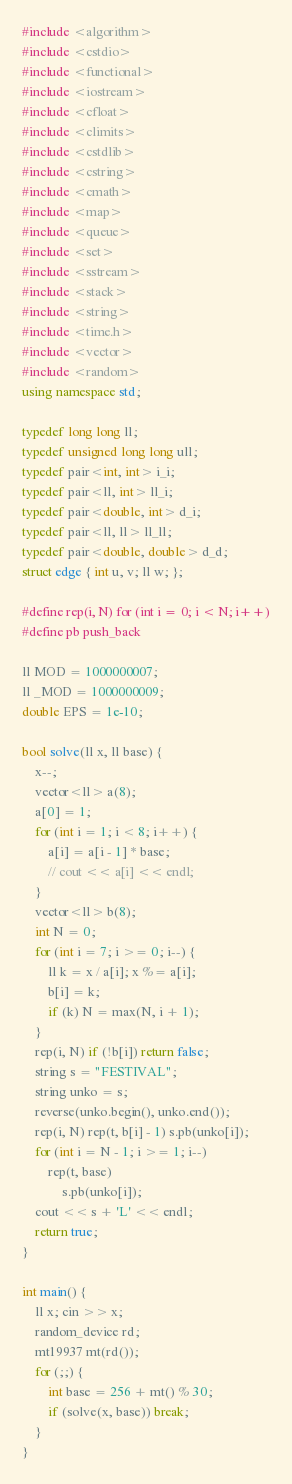<code> <loc_0><loc_0><loc_500><loc_500><_C++_>#include <algorithm>
#include <cstdio>
#include <functional>
#include <iostream>
#include <cfloat>
#include <climits>
#include <cstdlib>
#include <cstring>
#include <cmath>
#include <map>
#include <queue>
#include <set>
#include <sstream>
#include <stack>
#include <string>
#include <time.h>
#include <vector>
#include <random>
using namespace std;

typedef long long ll;
typedef unsigned long long ull;
typedef pair<int, int> i_i;
typedef pair<ll, int> ll_i;
typedef pair<double, int> d_i;
typedef pair<ll, ll> ll_ll;
typedef pair<double, double> d_d;
struct edge { int u, v; ll w; };

#define rep(i, N) for (int i = 0; i < N; i++)
#define pb push_back

ll MOD = 1000000007;
ll _MOD = 1000000009;
double EPS = 1e-10;

bool solve(ll x, ll base) {
	x--;
	vector<ll> a(8);
	a[0] = 1;
	for (int i = 1; i < 8; i++) {
		a[i] = a[i - 1] * base;
		// cout << a[i] << endl;
	}
	vector<ll> b(8);
	int N = 0;
	for (int i = 7; i >= 0; i--) {
		ll k = x / a[i]; x %= a[i];
		b[i] = k;
		if (k) N = max(N, i + 1);
	}
	rep(i, N) if (!b[i]) return false;
	string s = "FESTIVAL";
	string unko = s;
	reverse(unko.begin(), unko.end());
	rep(i, N) rep(t, b[i] - 1) s.pb(unko[i]);
	for (int i = N - 1; i >= 1; i--)
		rep(t, base)
			s.pb(unko[i]);
	cout << s + 'L' << endl;
	return true;
}

int main() {
	ll x; cin >> x;
	random_device rd;
	mt19937 mt(rd());
	for (;;) {
		int base = 256 + mt() % 30;
		if (solve(x, base)) break;
	}
}
</code> 